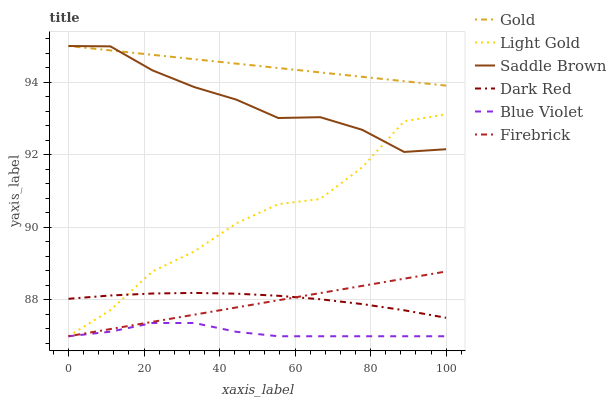Does Blue Violet have the minimum area under the curve?
Answer yes or no. Yes. Does Gold have the maximum area under the curve?
Answer yes or no. Yes. Does Dark Red have the minimum area under the curve?
Answer yes or no. No. Does Dark Red have the maximum area under the curve?
Answer yes or no. No. Is Firebrick the smoothest?
Answer yes or no. Yes. Is Light Gold the roughest?
Answer yes or no. Yes. Is Dark Red the smoothest?
Answer yes or no. No. Is Dark Red the roughest?
Answer yes or no. No. Does Firebrick have the lowest value?
Answer yes or no. Yes. Does Dark Red have the lowest value?
Answer yes or no. No. Does Saddle Brown have the highest value?
Answer yes or no. Yes. Does Dark Red have the highest value?
Answer yes or no. No. Is Dark Red less than Saddle Brown?
Answer yes or no. Yes. Is Gold greater than Dark Red?
Answer yes or no. Yes. Does Light Gold intersect Saddle Brown?
Answer yes or no. Yes. Is Light Gold less than Saddle Brown?
Answer yes or no. No. Is Light Gold greater than Saddle Brown?
Answer yes or no. No. Does Dark Red intersect Saddle Brown?
Answer yes or no. No. 